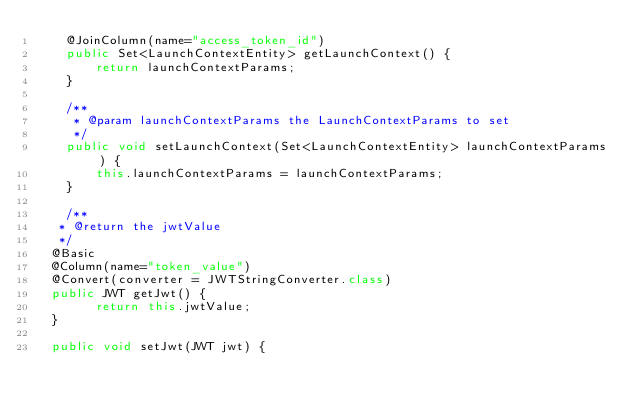<code> <loc_0><loc_0><loc_500><loc_500><_Java_>    @JoinColumn(name="access_token_id")
    public Set<LaunchContextEntity> getLaunchContext() {
        return launchContextParams;
    }

    /**
     * @param launchContextParams the LaunchContextParams to set
     */
    public void setLaunchContext(Set<LaunchContextEntity> launchContextParams) {
        this.launchContextParams = launchContextParams;
    }

    /**
	 * @return the jwtValue
	 */
	@Basic
	@Column(name="token_value")
	@Convert(converter = JWTStringConverter.class)
	public JWT getJwt() {
        return this.jwtValue;
	}

	public void setJwt(JWT jwt) {</code> 